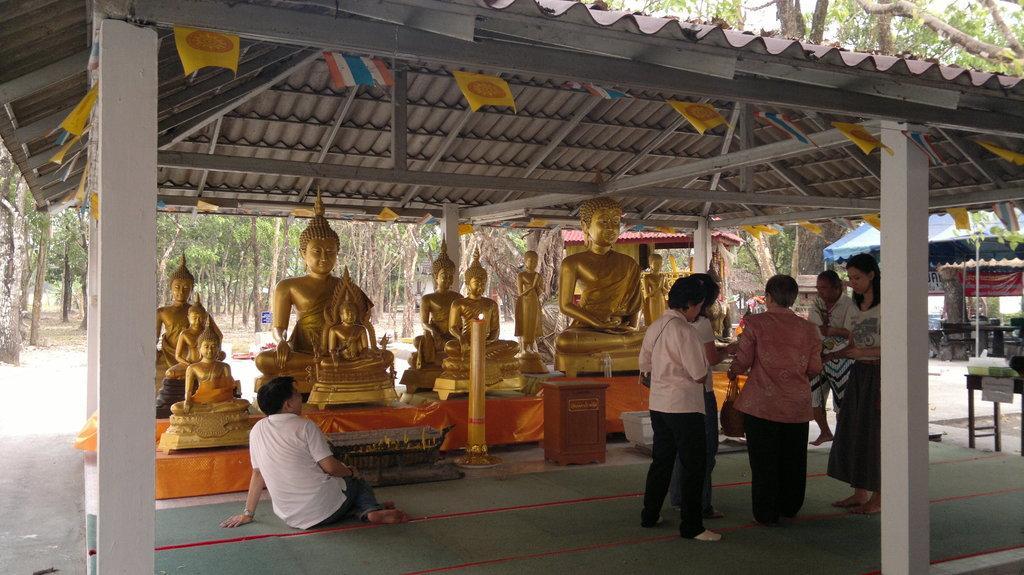Please provide a concise description of this image. In this image I can see few persons are standing on the ground and a person is sitting on the ground. I can see few statues of persons sitting which are gold in color, few pillars, few flags and the shed. In the background I can see few trees, a tent which is blue in color and the sky. 